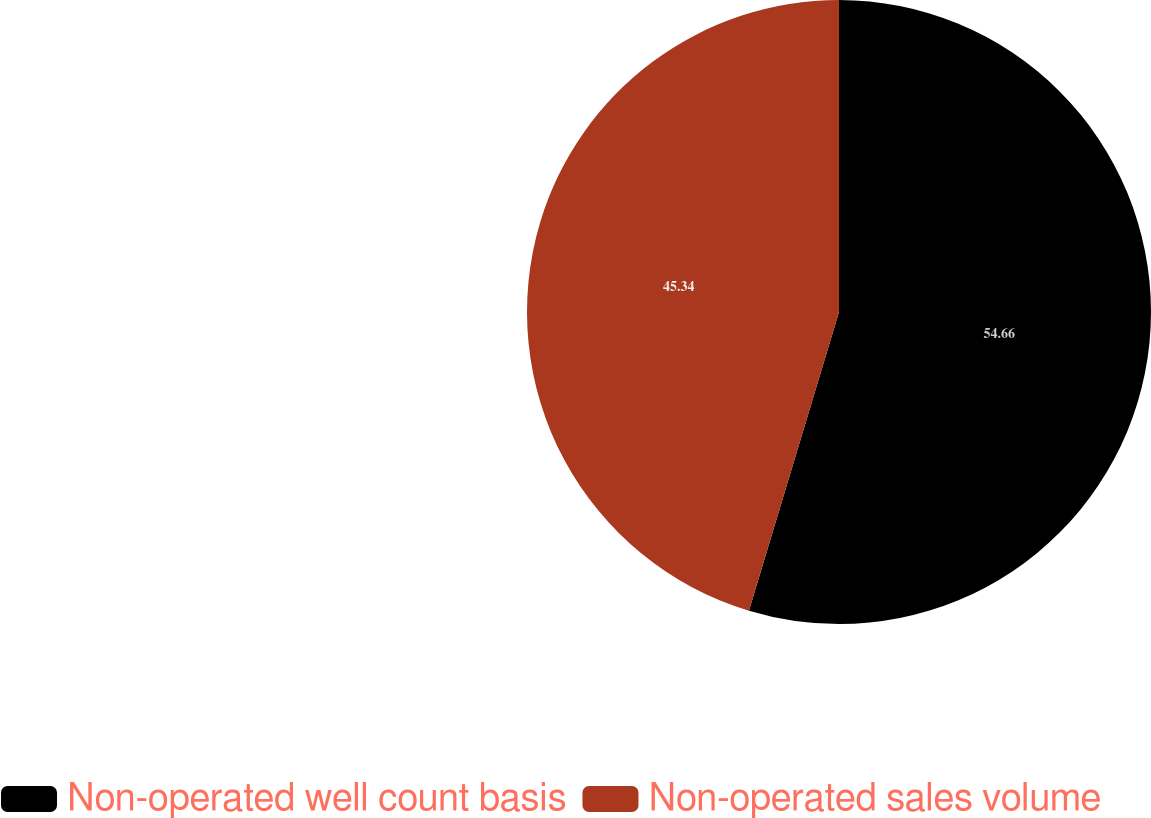Convert chart. <chart><loc_0><loc_0><loc_500><loc_500><pie_chart><fcel>Non-operated well count basis<fcel>Non-operated sales volume<nl><fcel>54.66%<fcel>45.34%<nl></chart> 